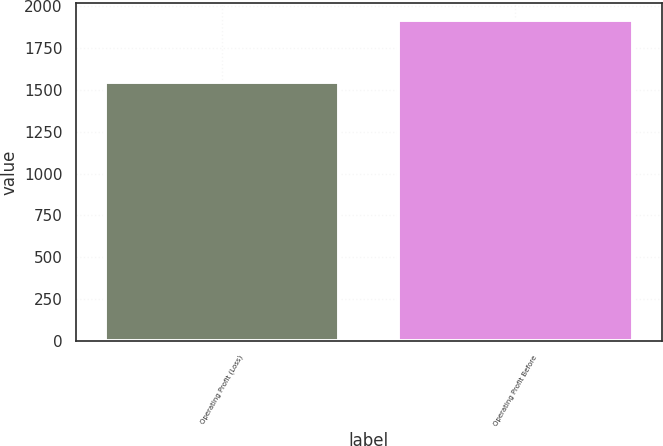<chart> <loc_0><loc_0><loc_500><loc_500><bar_chart><fcel>Operating Profit (Loss)<fcel>Operating Profit Before<nl><fcel>1547<fcel>1919<nl></chart> 